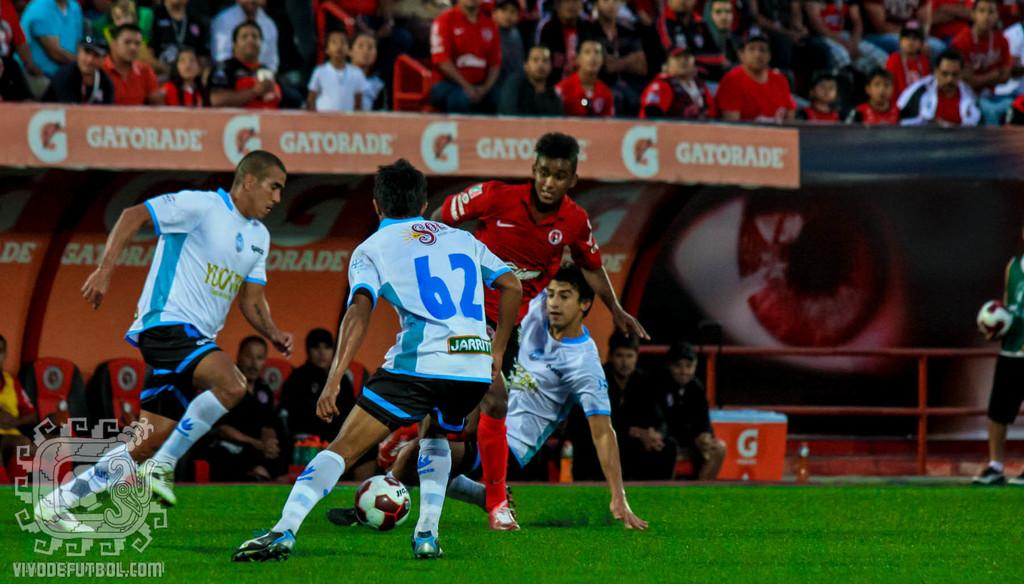<image>
Describe the image concisely. A soccer game being played in a stadium sponsored by Gatorade. 